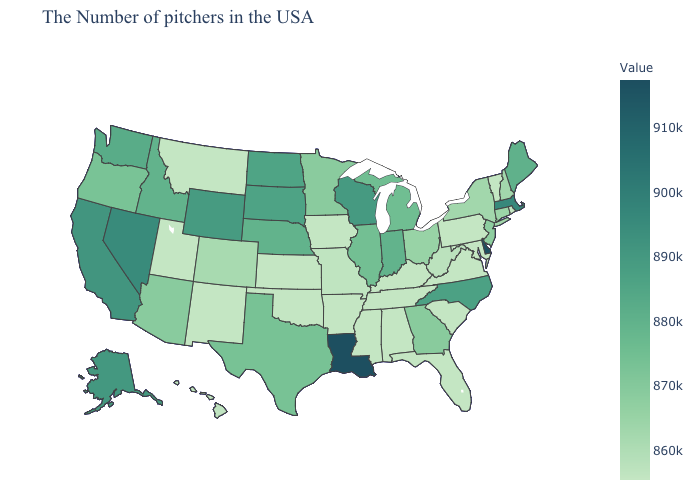Which states have the lowest value in the MidWest?
Write a very short answer. Iowa, Kansas. Among the states that border Tennessee , which have the highest value?
Short answer required. North Carolina. Which states have the highest value in the USA?
Answer briefly. Louisiana. Is the legend a continuous bar?
Be succinct. Yes. 